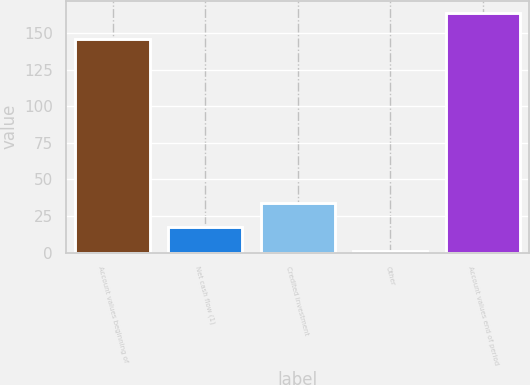Convert chart to OTSL. <chart><loc_0><loc_0><loc_500><loc_500><bar_chart><fcel>Account values beginning of<fcel>Net cash flow (1)<fcel>Credited investment<fcel>Other<fcel>Account values end of period<nl><fcel>146.1<fcel>17.38<fcel>33.66<fcel>1.1<fcel>163.9<nl></chart> 